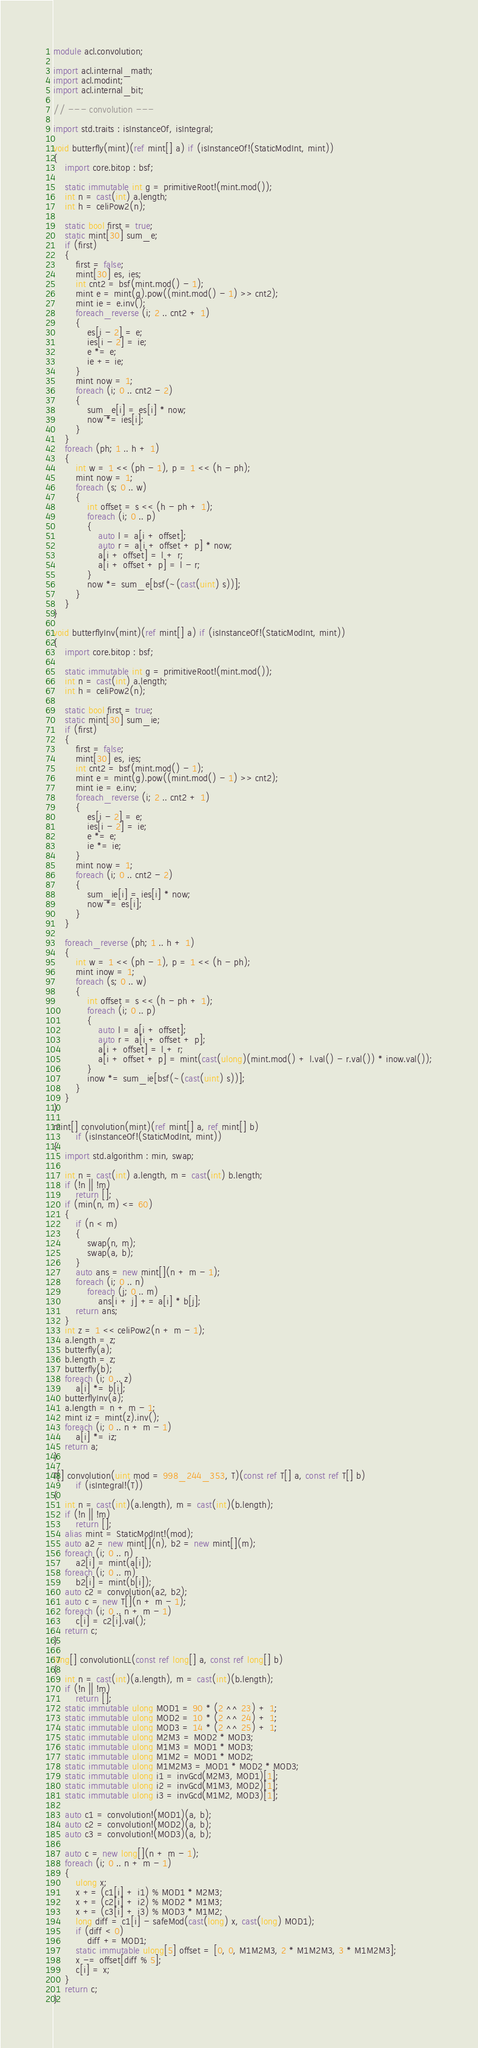<code> <loc_0><loc_0><loc_500><loc_500><_D_>module acl.convolution;

import acl.internal_math;
import acl.modint;
import acl.internal_bit;

// --- convolution ---

import std.traits : isInstanceOf, isIntegral;

void butterfly(mint)(ref mint[] a) if (isInstanceOf!(StaticModInt, mint))
{
    import core.bitop : bsf;

    static immutable int g = primitiveRoot!(mint.mod());
    int n = cast(int) a.length;
    int h = celiPow2(n);

    static bool first = true;
    static mint[30] sum_e;
    if (first)
    {
        first = false;
        mint[30] es, ies;
        int cnt2 = bsf(mint.mod() - 1);
        mint e = mint(g).pow((mint.mod() - 1) >> cnt2);
        mint ie = e.inv();
        foreach_reverse (i; 2 .. cnt2 + 1)
        {
            es[i - 2] = e;
            ies[i - 2] = ie;
            e *= e;
            ie += ie;
        }
        mint now = 1;
        foreach (i; 0 .. cnt2 - 2)
        {
            sum_e[i] = es[i] * now;
            now *= ies[i];
        }
    }
    foreach (ph; 1 .. h + 1)
    {
        int w = 1 << (ph - 1), p = 1 << (h - ph);
        mint now = 1;
        foreach (s; 0 .. w)
        {
            int offset = s << (h - ph + 1);
            foreach (i; 0 .. p)
            {
                auto l = a[i + offset];
                auto r = a[i + offset + p] * now;
                a[i + offset] = l + r;
                a[i + offset + p] = l - r;
            }
            now *= sum_e[bsf(~(cast(uint) s))];
        }
    }
}

void butterflyInv(mint)(ref mint[] a) if (isInstanceOf!(StaticModInt, mint))
{
    import core.bitop : bsf;

    static immutable int g = primitiveRoot!(mint.mod());
    int n = cast(int) a.length;
    int h = celiPow2(n);

    static bool first = true;
    static mint[30] sum_ie;
    if (first)
    {
        first = false;
        mint[30] es, ies;
        int cnt2 = bsf(mint.mod() - 1);
        mint e = mint(g).pow((mint.mod() - 1) >> cnt2);
        mint ie = e.inv;
        foreach_reverse (i; 2 .. cnt2 + 1)
        {
            es[i - 2] = e;
            ies[i - 2] = ie;
            e *= e;
            ie *= ie;
        }
        mint now = 1;
        foreach (i; 0 .. cnt2 - 2)
        {
            sum_ie[i] = ies[i] * now;
            now *= es[i];
        }
    }

    foreach_reverse (ph; 1 .. h + 1)
    {
        int w = 1 << (ph - 1), p = 1 << (h - ph);
        mint inow = 1;
        foreach (s; 0 .. w)
        {
            int offset = s << (h - ph + 1);
            foreach (i; 0 .. p)
            {
                auto l = a[i + offset];
                auto r = a[i + offset + p];
                a[i + offset] = l + r;
                a[i + offset + p] = mint(cast(ulong)(mint.mod() + l.val() - r.val()) * inow.val());
            }
            inow *= sum_ie[bsf(~(cast(uint) s))];
        }
    }
}

mint[] convolution(mint)(ref mint[] a, ref mint[] b)
        if (isInstanceOf!(StaticModInt, mint))
{
    import std.algorithm : min, swap;

    int n = cast(int) a.length, m = cast(int) b.length;
    if (!n || !m)
        return [];
    if (min(n, m) <= 60)
    {
        if (n < m)
        {
            swap(n, m);
            swap(a, b);
        }
        auto ans = new mint[](n + m - 1);
        foreach (i; 0 .. n)
            foreach (j; 0 .. m)
                ans[i + j] += a[i] * b[j];
        return ans;
    }
    int z = 1 << celiPow2(n + m - 1);
    a.length = z;
    butterfly(a);
    b.length = z;
    butterfly(b);
    foreach (i; 0 .. z)
        a[i] *= b[i];
    butterflyInv(a);
    a.length = n + m - 1;
    mint iz = mint(z).inv();
    foreach (i; 0 .. n + m - 1)
        a[i] *= iz;
    return a;
}

T[] convolution(uint mod = 998_244_353, T)(const ref T[] a, const ref T[] b)
        if (isIntegral!(T))
{
    int n = cast(int)(a.length), m = cast(int)(b.length);
    if (!n || !m)
        return [];
    alias mint = StaticModInt!(mod);
    auto a2 = new mint[](n), b2 = new mint[](m);
    foreach (i; 0 .. n)
        a2[i] = mint(a[i]);
    foreach (i; 0 .. m)
        b2[i] = mint(b[i]);
    auto c2 = convolution(a2, b2);
    auto c = new T[](n + m - 1);
    foreach (i; 0 .. n + m - 1)
        c[i] = c2[i].val();
    return c;
}

long[] convolutionLL(const ref long[] a, const ref long[] b)
{
    int n = cast(int)(a.length), m = cast(int)(b.length);
    if (!n || !m)
        return [];
    static immutable ulong MOD1 = 90 * (2 ^^ 23) + 1;
    static immutable ulong MOD2 = 10 * (2 ^^ 24) + 1;
    static immutable ulong MOD3 = 14 * (2 ^^ 25) + 1;
    static immutable ulong M2M3 = MOD2 * MOD3;
    static immutable ulong M1M3 = MOD1 * MOD3;
    static immutable ulong M1M2 = MOD1 * MOD2;
    static immutable ulong M1M2M3 = MOD1 * MOD2 * MOD3;
    static immutable ulong i1 = invGcd(M2M3, MOD1)[1];
    static immutable ulong i2 = invGcd(M1M3, MOD2)[1];
    static immutable ulong i3 = invGcd(M1M2, MOD3)[1];

    auto c1 = convolution!(MOD1)(a, b);
    auto c2 = convolution!(MOD2)(a, b);
    auto c3 = convolution!(MOD3)(a, b);

    auto c = new long[](n + m - 1);
    foreach (i; 0 .. n + m - 1)
    {
        ulong x;
        x += (c1[i] + i1) % MOD1 * M2M3;
        x += (c2[i] + i2) % MOD2 * M1M3;
        x += (c3[i] + i3) % MOD3 * M1M2;
        long diff = c1[i] - safeMod(cast(long) x, cast(long) MOD1);
        if (diff < 0)
            diff += MOD1;
        static immutable ulong[5] offset = [0, 0, M1M2M3, 2 * M1M2M3, 3 * M1M2M3];
        x -= offset[diff % 5];
        c[i] = x;
    }
    return c;
}
</code> 